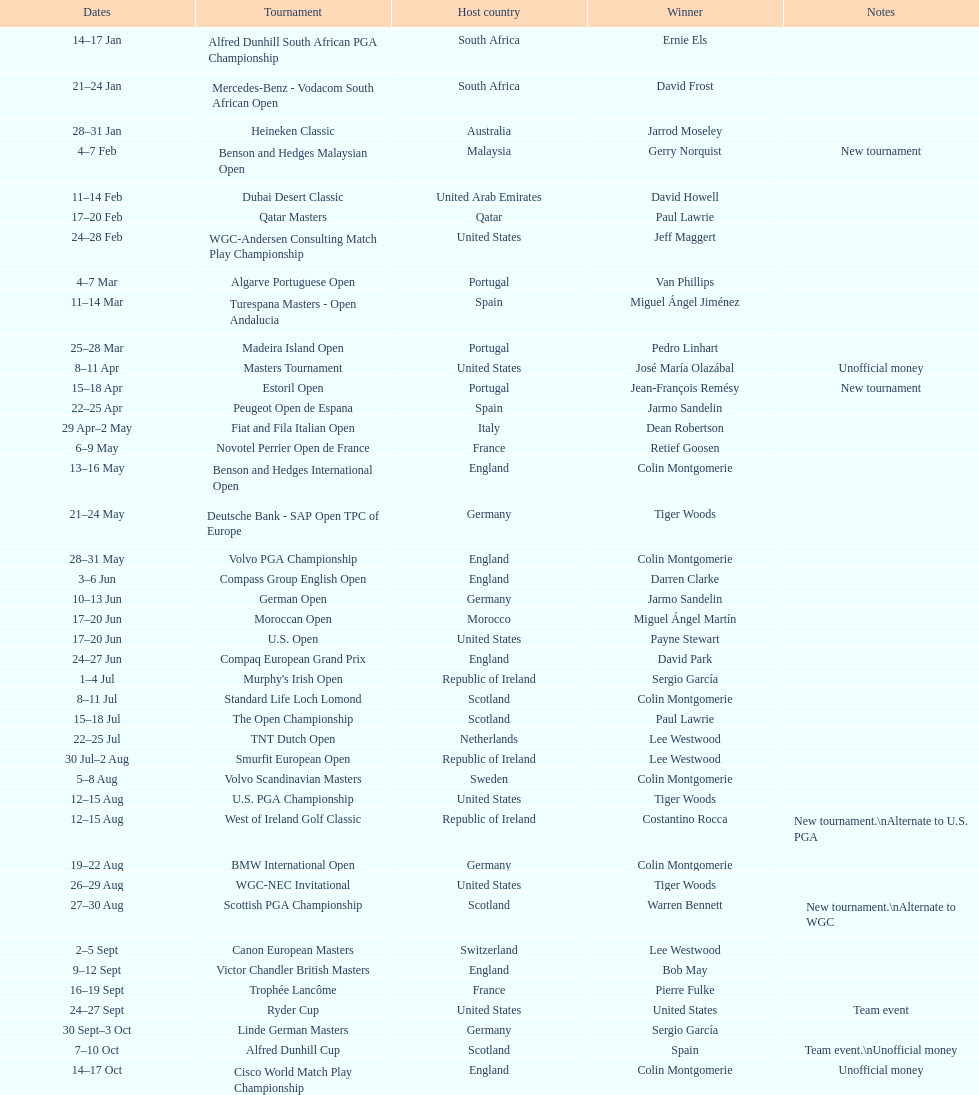Which country was named during the inaugural instance of a novel tournament? Malaysia. 